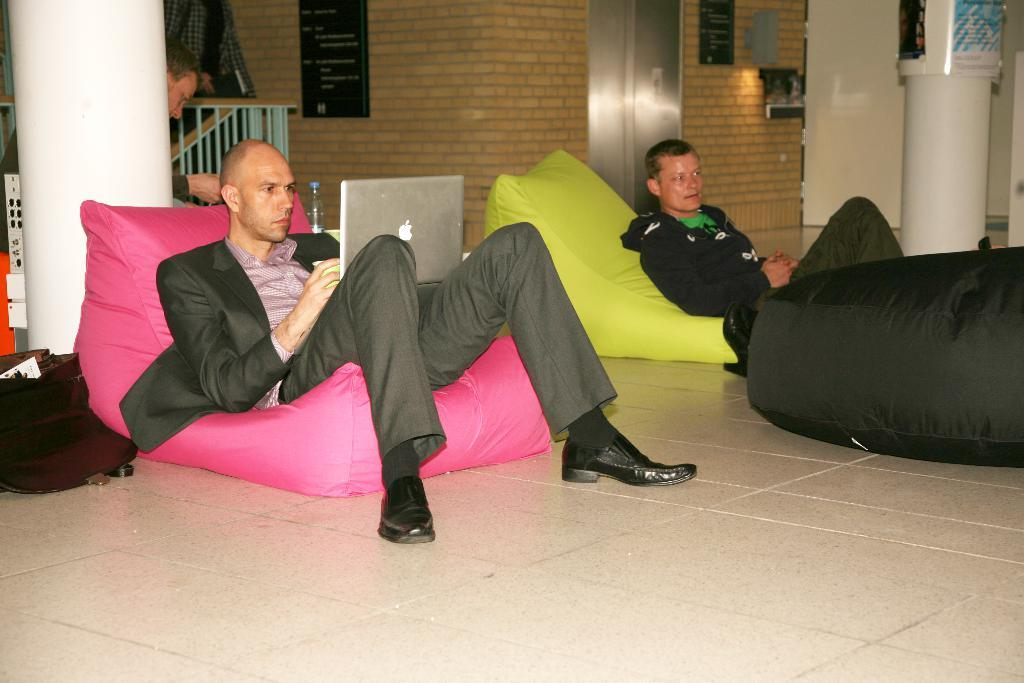What type of seating is visible in the image? There are bean bags in the image. What electronic devices can be seen in the image? There are laptops in the image. What type of containers are present in the image? There are bottles in the image. Who or what is present in the image? There are people in the image. What type of beds can be seen in the image? There are no beds present in the image. What type of minister is depicted in the image? There is no minister depicted in the image. 